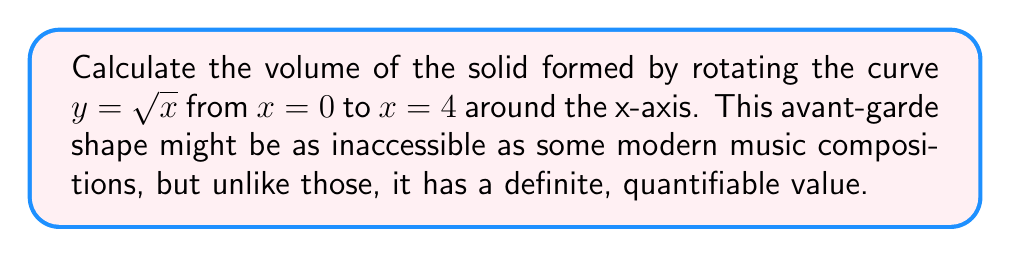Solve this math problem. To find the volume of a solid formed by rotating a curve around the x-axis, we use the disk method:

1) The volume is given by the integral:
   $$V = \pi \int_{a}^{b} [f(x)]^2 dx$$
   where $f(x)$ is the function being rotated.

2) In this case, $f(x) = \sqrt{x}$, $a = 0$, and $b = 4$.

3) Substituting into the formula:
   $$V = \pi \int_{0}^{4} (\sqrt{x})^2 dx = \pi \int_{0}^{4} x dx$$

4) Integrate:
   $$V = \pi [\frac{1}{2}x^2]_{0}^{4}$$

5) Evaluate the integral:
   $$V = \pi (\frac{1}{2}(4^2) - \frac{1}{2}(0^2)) = \pi (8 - 0) = 8\pi$$

Thus, the volume of the solid is $8\pi$ cubic units.
Answer: $8\pi$ cubic units 